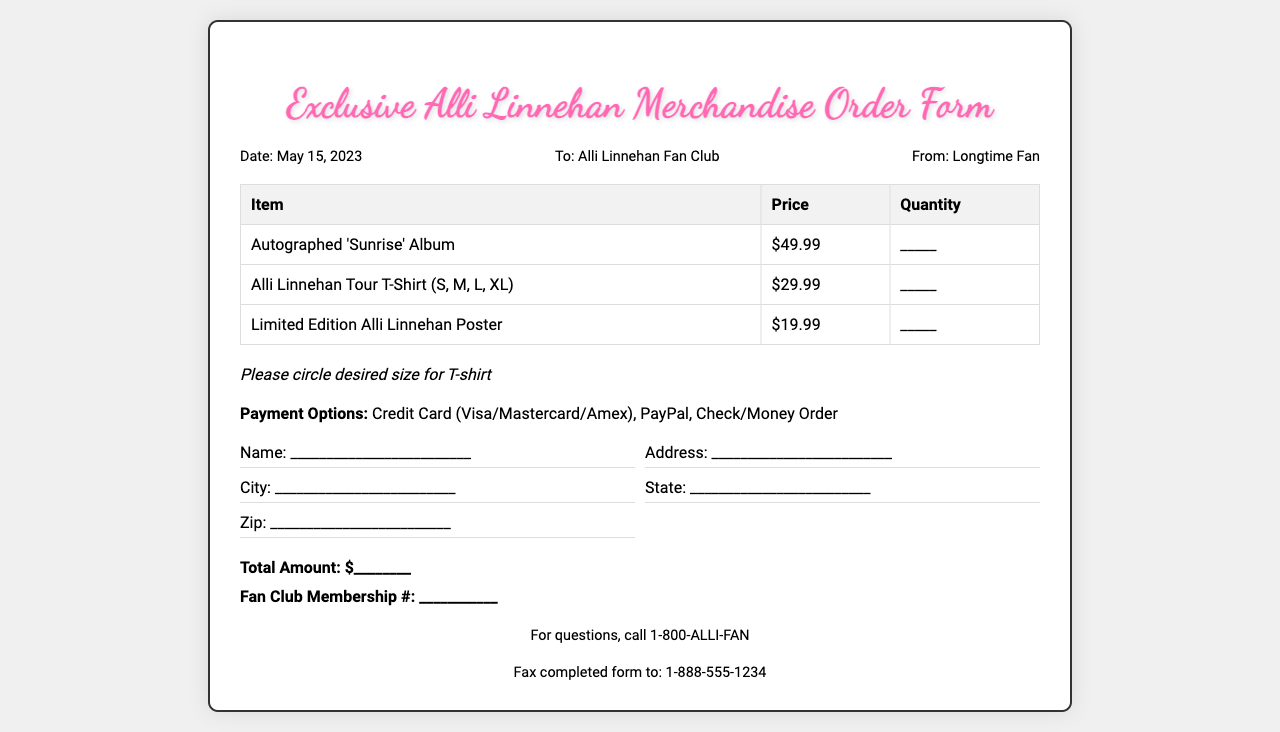What is the date of the order form? The date is explicitly stated in the document under the header information section.
Answer: May 15, 2023 What are the payment options available? The payment options are listed fully in a dedicated section of the document.
Answer: Credit Card (Visa/Mastercard/Amex), PayPal, Check/Money Order How much does the Alli Linnehan Tour T-Shirt cost? The price is shown in the table under the price column specifically for that item.
Answer: $29.99 What is the total amount to be filled in? The document includes a section for the total amount, suggesting the user will input a value.
Answer: $________ What sizes are available for the T-shirt? The available sizes for the T-shirt are mentioned directly in the item description.
Answer: S, M, L, XL How many items can be ordered for the autographed album? The quantity field is left blank for the user to fill in as per their preference.
Answer: _____ What is the phone number for questions? The contact information for questions is provided at the bottom of the document.
Answer: 1-800-ALLI-FAN What is the fax number to send the form to? The fax number is stated clearly in the fax instructions section of the document.
Answer: 1-888-555-1234 